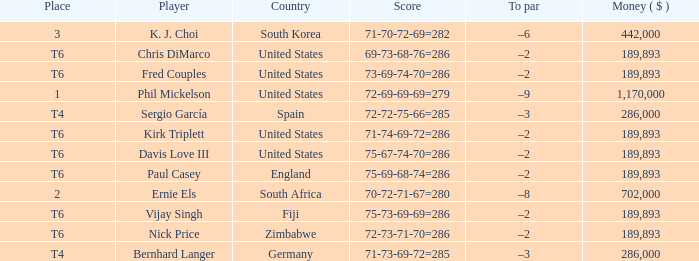What is the least money ($) when the country is united states and the player is kirk triplett? 189893.0. 